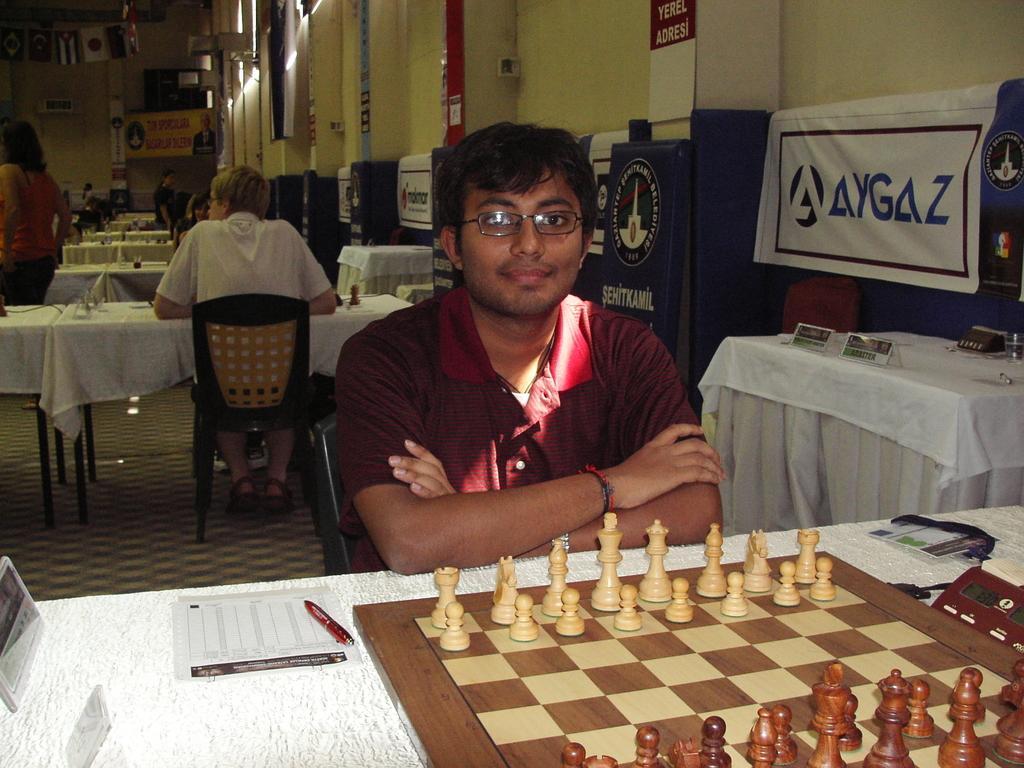Please provide a concise description of this image. In this picture we can see some people where two men here are sitting on chair and in front of them there is table and on table we can see paper, pen, digital clock, chess board, tag and in background we can see wall, banner, some person standing. 